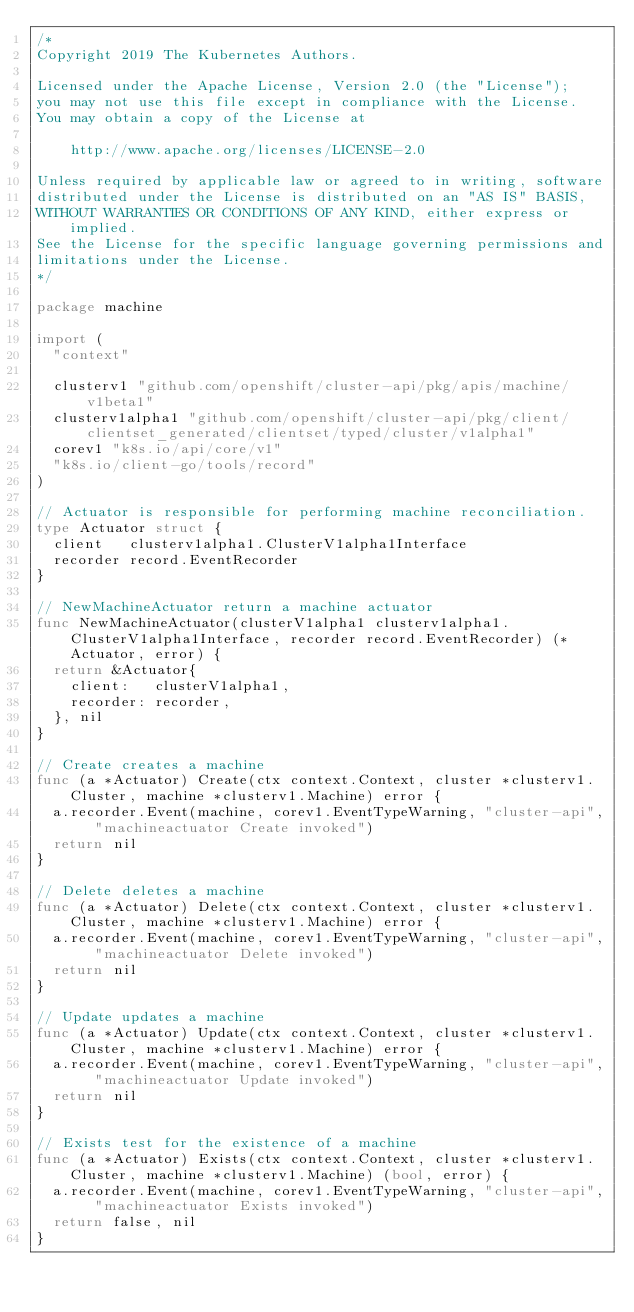Convert code to text. <code><loc_0><loc_0><loc_500><loc_500><_Go_>/*
Copyright 2019 The Kubernetes Authors.

Licensed under the Apache License, Version 2.0 (the "License");
you may not use this file except in compliance with the License.
You may obtain a copy of the License at

    http://www.apache.org/licenses/LICENSE-2.0

Unless required by applicable law or agreed to in writing, software
distributed under the License is distributed on an "AS IS" BASIS,
WITHOUT WARRANTIES OR CONDITIONS OF ANY KIND, either express or implied.
See the License for the specific language governing permissions and
limitations under the License.
*/

package machine

import (
	"context"

	clusterv1 "github.com/openshift/cluster-api/pkg/apis/machine/v1beta1"
	clusterv1alpha1 "github.com/openshift/cluster-api/pkg/client/clientset_generated/clientset/typed/cluster/v1alpha1"
	corev1 "k8s.io/api/core/v1"
	"k8s.io/client-go/tools/record"
)

// Actuator is responsible for performing machine reconciliation.
type Actuator struct {
	client   clusterv1alpha1.ClusterV1alpha1Interface
	recorder record.EventRecorder
}

// NewMachineActuator return a machine actuator
func NewMachineActuator(clusterV1alpha1 clusterv1alpha1.ClusterV1alpha1Interface, recorder record.EventRecorder) (*Actuator, error) {
	return &Actuator{
		client:   clusterV1alpha1,
		recorder: recorder,
	}, nil
}

// Create creates a machine
func (a *Actuator) Create(ctx context.Context, cluster *clusterv1.Cluster, machine *clusterv1.Machine) error {
	a.recorder.Event(machine, corev1.EventTypeWarning, "cluster-api", "machineactuator Create invoked")
	return nil
}

// Delete deletes a machine
func (a *Actuator) Delete(ctx context.Context, cluster *clusterv1.Cluster, machine *clusterv1.Machine) error {
	a.recorder.Event(machine, corev1.EventTypeWarning, "cluster-api", "machineactuator Delete invoked")
	return nil
}

// Update updates a machine
func (a *Actuator) Update(ctx context.Context, cluster *clusterv1.Cluster, machine *clusterv1.Machine) error {
	a.recorder.Event(machine, corev1.EventTypeWarning, "cluster-api", "machineactuator Update invoked")
	return nil
}

// Exists test for the existence of a machine
func (a *Actuator) Exists(ctx context.Context, cluster *clusterv1.Cluster, machine *clusterv1.Machine) (bool, error) {
	a.recorder.Event(machine, corev1.EventTypeWarning, "cluster-api", "machineactuator Exists invoked")
	return false, nil
}
</code> 